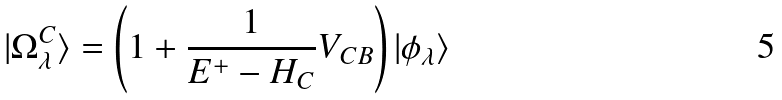Convert formula to latex. <formula><loc_0><loc_0><loc_500><loc_500>| \Omega _ { \lambda } ^ { C } \rangle = \left ( 1 + \frac { 1 } { E ^ { + } - H _ { C } } V _ { C B } \right ) | \phi _ { \lambda } \rangle</formula> 